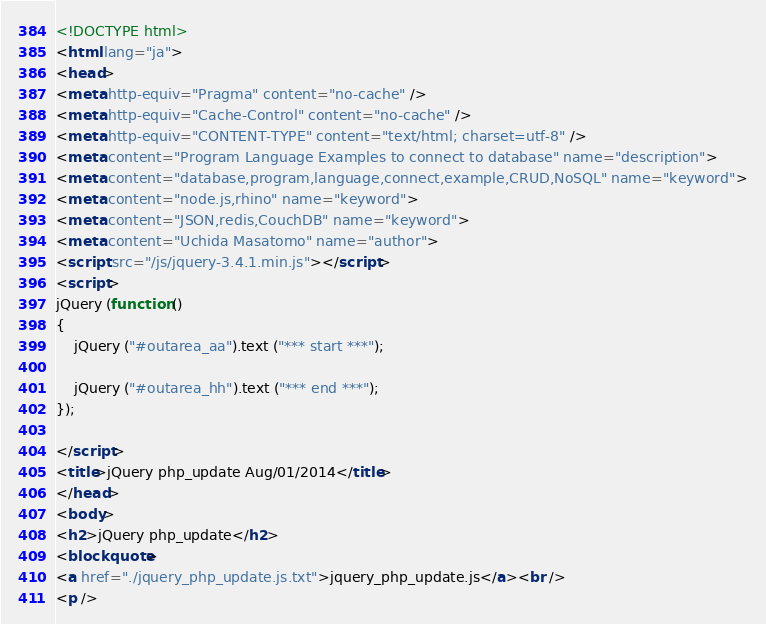<code> <loc_0><loc_0><loc_500><loc_500><_HTML_><!DOCTYPE html>
<html lang="ja">
<head>
<meta http-equiv="Pragma" content="no-cache" />
<meta http-equiv="Cache-Control" content="no-cache" />
<meta http-equiv="CONTENT-TYPE" content="text/html; charset=utf-8" />
<meta content="Program Language Examples to connect to database" name="description">
<meta content="database,program,language,connect,example,CRUD,NoSQL" name="keyword">
<meta content="node.js,rhino" name="keyword">
<meta content="JSON,redis,CouchDB" name="keyword">
<meta content="Uchida Masatomo" name="author">
<script src="/js/jquery-3.4.1.min.js"></script>
<script>
jQuery (function ()
{
	jQuery ("#outarea_aa").text ("*** start ***");

	jQuery ("#outarea_hh").text ("*** end ***");
});

</script>
<title>jQuery php_update Aug/01/2014</title>
</head>
<body>
<h2>jQuery php_update</h2>
<blockquote>
<a href="./jquery_php_update.js.txt">jquery_php_update.js</a><br />
<p /> </code> 